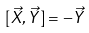<formula> <loc_0><loc_0><loc_500><loc_500>[ \vec { X } , \vec { Y } ] = - \vec { Y }</formula> 